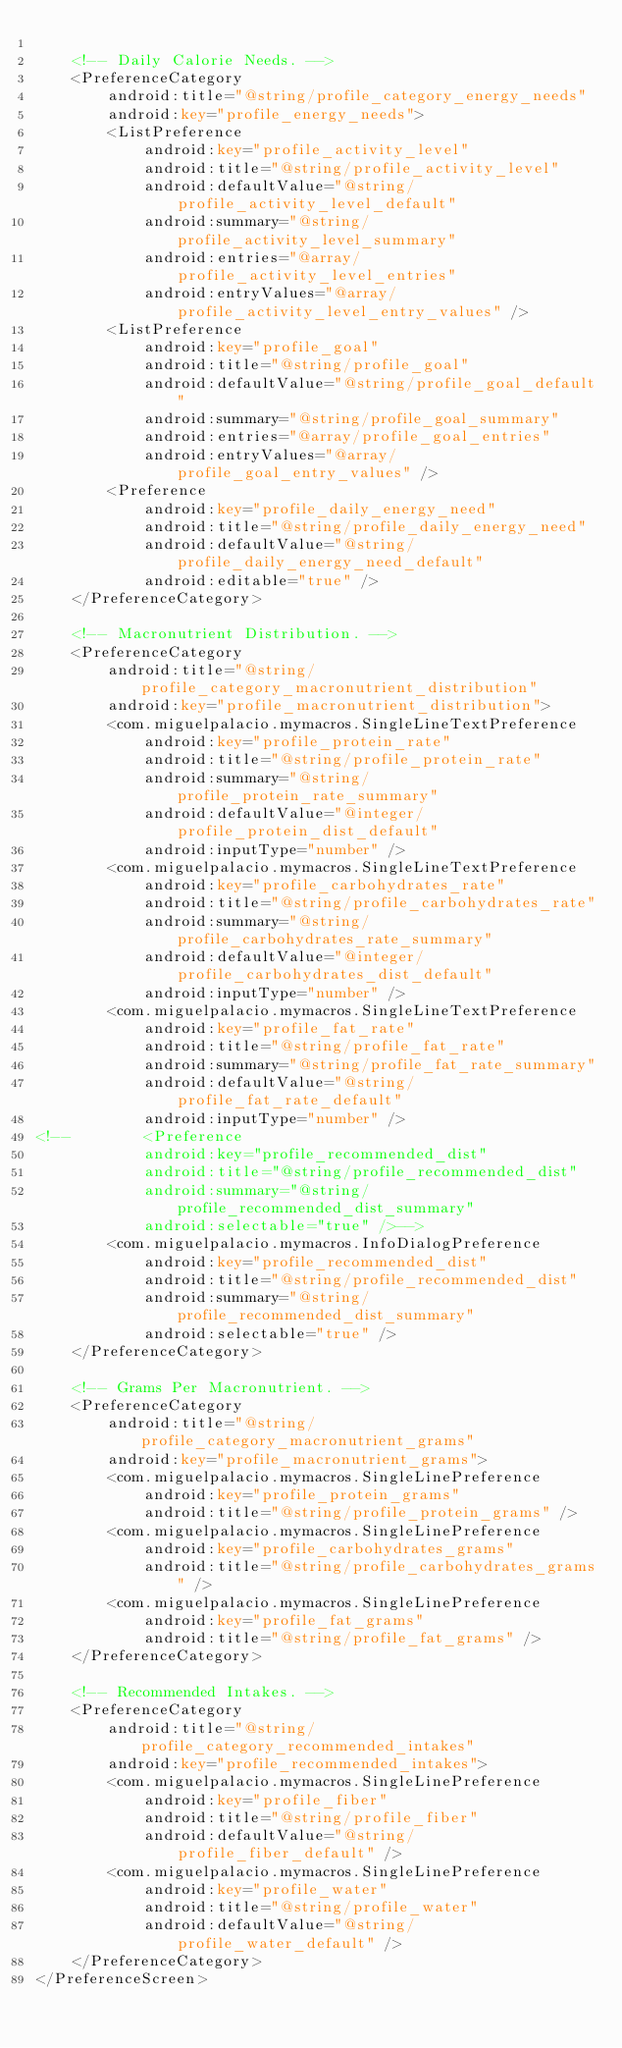<code> <loc_0><loc_0><loc_500><loc_500><_XML_>
    <!-- Daily Calorie Needs. -->
    <PreferenceCategory
        android:title="@string/profile_category_energy_needs"
        android:key="profile_energy_needs">
        <ListPreference
            android:key="profile_activity_level"
            android:title="@string/profile_activity_level"
            android:defaultValue="@string/profile_activity_level_default"
            android:summary="@string/profile_activity_level_summary"
            android:entries="@array/profile_activity_level_entries"
            android:entryValues="@array/profile_activity_level_entry_values" />
        <ListPreference
            android:key="profile_goal"
            android:title="@string/profile_goal"
            android:defaultValue="@string/profile_goal_default"
            android:summary="@string/profile_goal_summary"
            android:entries="@array/profile_goal_entries"
            android:entryValues="@array/profile_goal_entry_values" />
        <Preference
            android:key="profile_daily_energy_need"
            android:title="@string/profile_daily_energy_need"
            android:defaultValue="@string/profile_daily_energy_need_default"
            android:editable="true" />
    </PreferenceCategory>

    <!-- Macronutrient Distribution. -->
    <PreferenceCategory
        android:title="@string/profile_category_macronutrient_distribution"
        android:key="profile_macronutrient_distribution">
        <com.miguelpalacio.mymacros.SingleLineTextPreference
            android:key="profile_protein_rate"
            android:title="@string/profile_protein_rate"
            android:summary="@string/profile_protein_rate_summary"
            android:defaultValue="@integer/profile_protein_dist_default"
            android:inputType="number" />
        <com.miguelpalacio.mymacros.SingleLineTextPreference
            android:key="profile_carbohydrates_rate"
            android:title="@string/profile_carbohydrates_rate"
            android:summary="@string/profile_carbohydrates_rate_summary"
            android:defaultValue="@integer/profile_carbohydrates_dist_default"
            android:inputType="number" />
        <com.miguelpalacio.mymacros.SingleLineTextPreference
            android:key="profile_fat_rate"
            android:title="@string/profile_fat_rate"
            android:summary="@string/profile_fat_rate_summary"
            android:defaultValue="@string/profile_fat_rate_default"
            android:inputType="number" />
<!--        <Preference
            android:key="profile_recommended_dist"
            android:title="@string/profile_recommended_dist"
            android:summary="@string/profile_recommended_dist_summary"
            android:selectable="true" />-->
        <com.miguelpalacio.mymacros.InfoDialogPreference
            android:key="profile_recommended_dist"
            android:title="@string/profile_recommended_dist"
            android:summary="@string/profile_recommended_dist_summary"
            android:selectable="true" />
    </PreferenceCategory>

    <!-- Grams Per Macronutrient. -->
    <PreferenceCategory
        android:title="@string/profile_category_macronutrient_grams"
        android:key="profile_macronutrient_grams">
        <com.miguelpalacio.mymacros.SingleLinePreference
            android:key="profile_protein_grams"
            android:title="@string/profile_protein_grams" />
        <com.miguelpalacio.mymacros.SingleLinePreference
            android:key="profile_carbohydrates_grams"
            android:title="@string/profile_carbohydrates_grams" />
        <com.miguelpalacio.mymacros.SingleLinePreference
            android:key="profile_fat_grams"
            android:title="@string/profile_fat_grams" />
    </PreferenceCategory>

    <!-- Recommended Intakes. -->
    <PreferenceCategory
        android:title="@string/profile_category_recommended_intakes"
        android:key="profile_recommended_intakes">
        <com.miguelpalacio.mymacros.SingleLinePreference
            android:key="profile_fiber"
            android:title="@string/profile_fiber"
            android:defaultValue="@string/profile_fiber_default" />
        <com.miguelpalacio.mymacros.SingleLinePreference
            android:key="profile_water"
            android:title="@string/profile_water"
            android:defaultValue="@string/profile_water_default" />
    </PreferenceCategory>
</PreferenceScreen></code> 